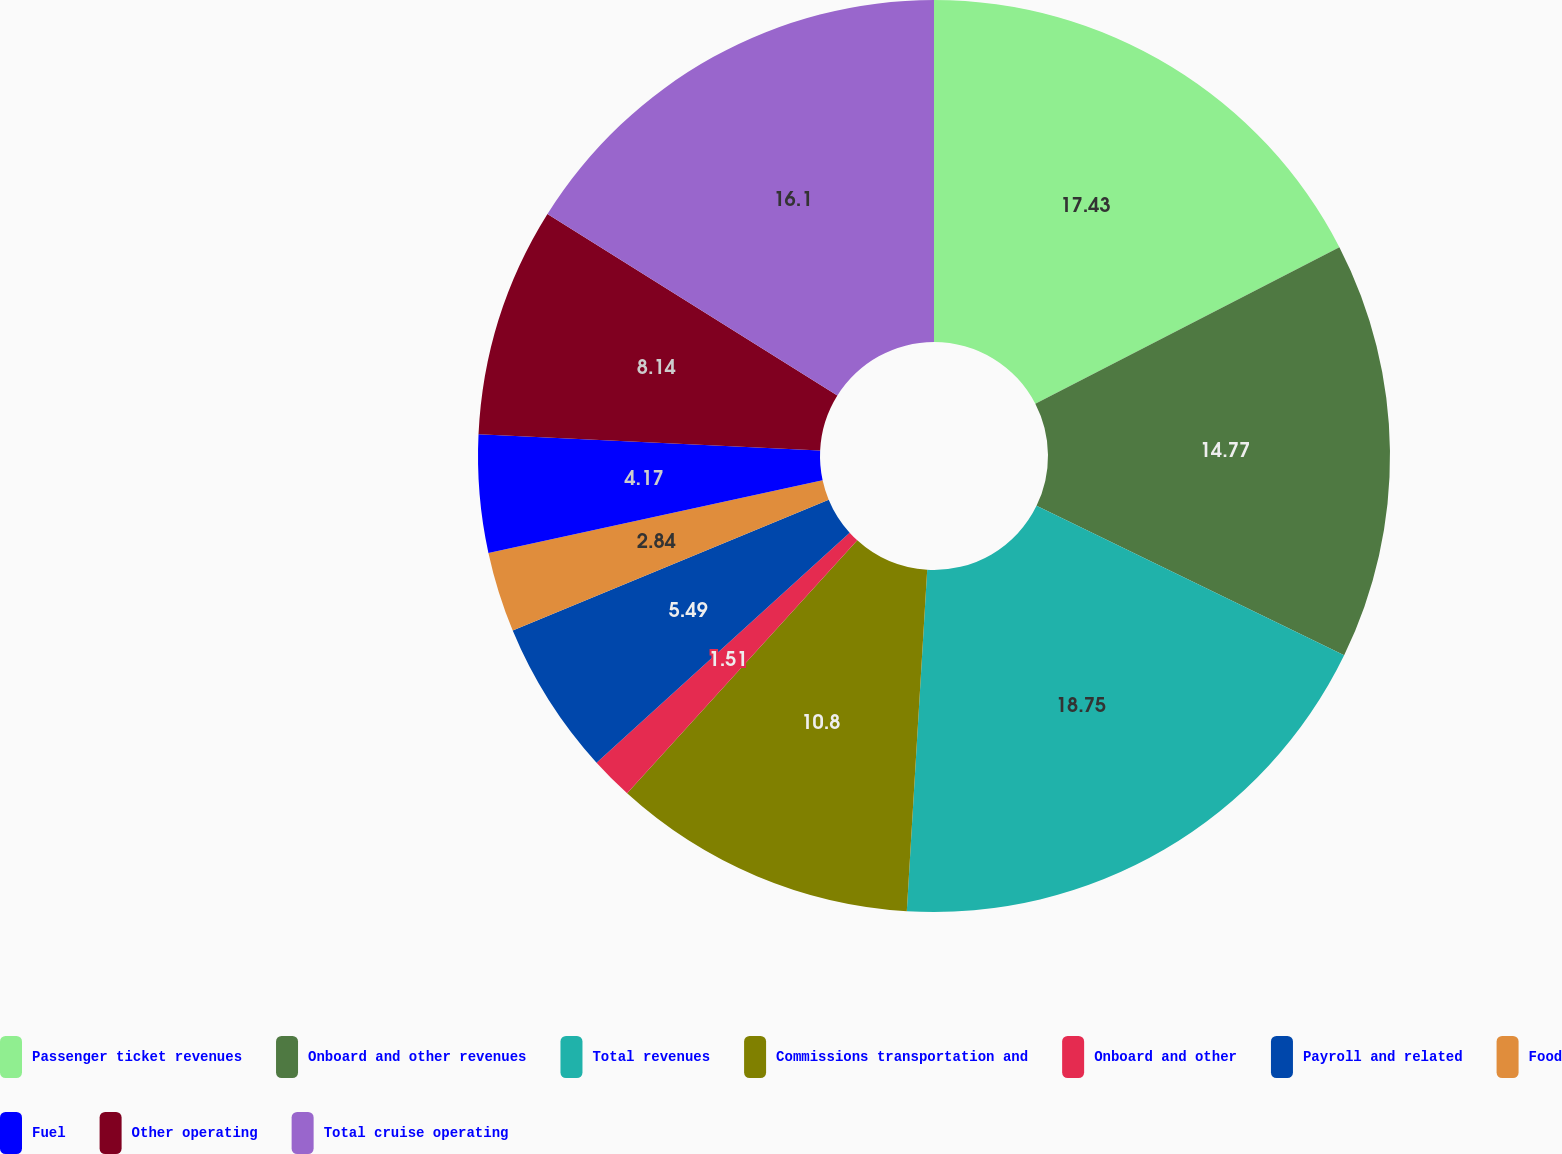Convert chart. <chart><loc_0><loc_0><loc_500><loc_500><pie_chart><fcel>Passenger ticket revenues<fcel>Onboard and other revenues<fcel>Total revenues<fcel>Commissions transportation and<fcel>Onboard and other<fcel>Payroll and related<fcel>Food<fcel>Fuel<fcel>Other operating<fcel>Total cruise operating<nl><fcel>17.43%<fcel>14.77%<fcel>18.75%<fcel>10.8%<fcel>1.51%<fcel>5.49%<fcel>2.84%<fcel>4.17%<fcel>8.14%<fcel>16.1%<nl></chart> 